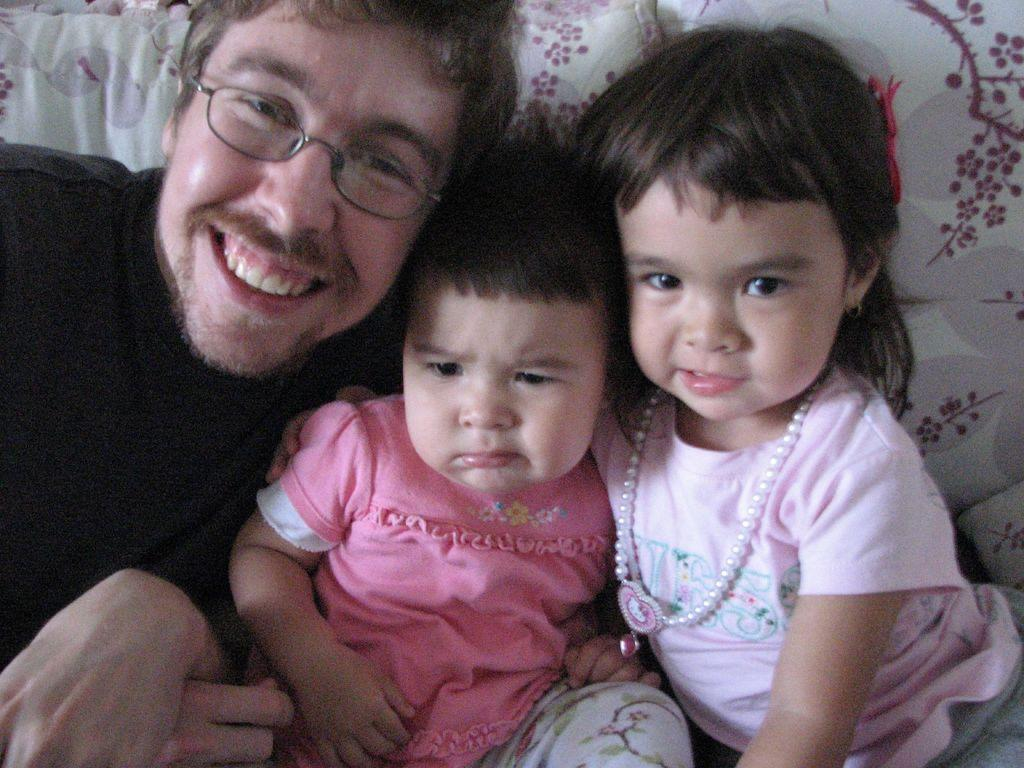How many people are in the image? There are three people in the image. What are the people doing in the image? The three people are sitting on a couch. Can you describe one of the people in the image? There is a man with spectacles in the image. What is the man with spectacles doing? The man with spectacles is smiling. What type of clover is growing on the road in the image? There is no clover or road present in the image; it features three people sitting on a couch. How is the string tied around the man's spectacles in the image? There is no string tied around the man's spectacles in the image; he is simply wearing them. 